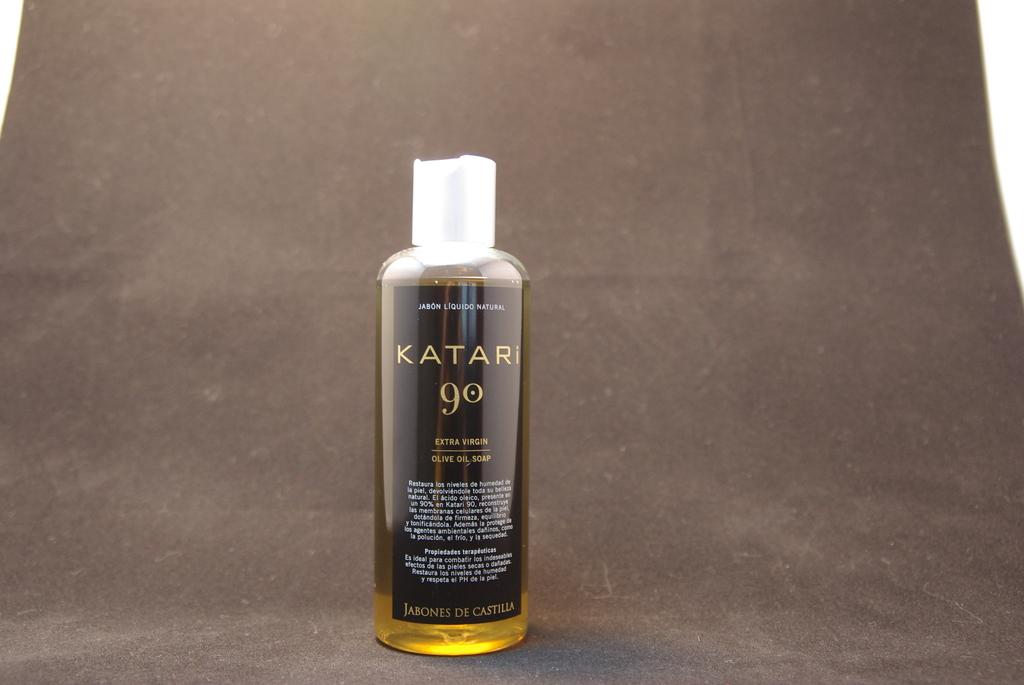<image>
Provide a brief description of the given image. A single bottle of Katari 90 extra virgin olive oil is on a dark background. 